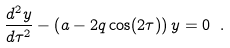Convert formula to latex. <formula><loc_0><loc_0><loc_500><loc_500>\frac { d ^ { 2 } y } { d \tau ^ { 2 } } - \left ( a - 2 q \cos ( 2 \tau ) \right ) y = 0 \ .</formula> 